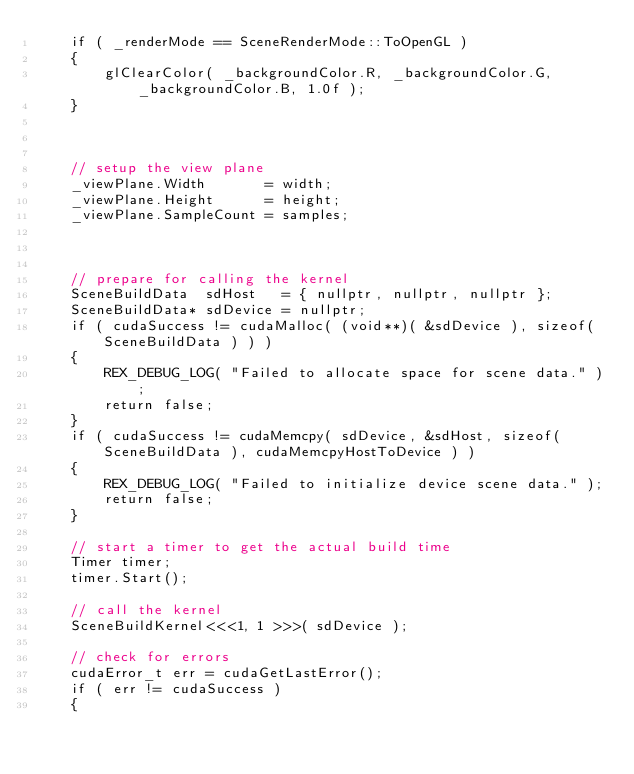<code> <loc_0><loc_0><loc_500><loc_500><_Cuda_>    if ( _renderMode == SceneRenderMode::ToOpenGL )
    {
        glClearColor( _backgroundColor.R, _backgroundColor.G, _backgroundColor.B, 1.0f );
    }



    // setup the view plane
    _viewPlane.Width       = width;
    _viewPlane.Height      = height;
    _viewPlane.SampleCount = samples;


    
    // prepare for calling the kernel
    SceneBuildData  sdHost   = { nullptr, nullptr, nullptr };
    SceneBuildData* sdDevice = nullptr;
    if ( cudaSuccess != cudaMalloc( (void**)( &sdDevice ), sizeof( SceneBuildData ) ) )
    {
        REX_DEBUG_LOG( "Failed to allocate space for scene data." );
        return false;
    }
    if ( cudaSuccess != cudaMemcpy( sdDevice, &sdHost, sizeof( SceneBuildData ), cudaMemcpyHostToDevice ) )
    {
        REX_DEBUG_LOG( "Failed to initialize device scene data." );
        return false;
    }

    // start a timer to get the actual build time
    Timer timer;
    timer.Start();

    // call the kernel
    SceneBuildKernel<<<1, 1 >>>( sdDevice );

    // check for errors
    cudaError_t err = cudaGetLastError();
    if ( err != cudaSuccess )
    {</code> 